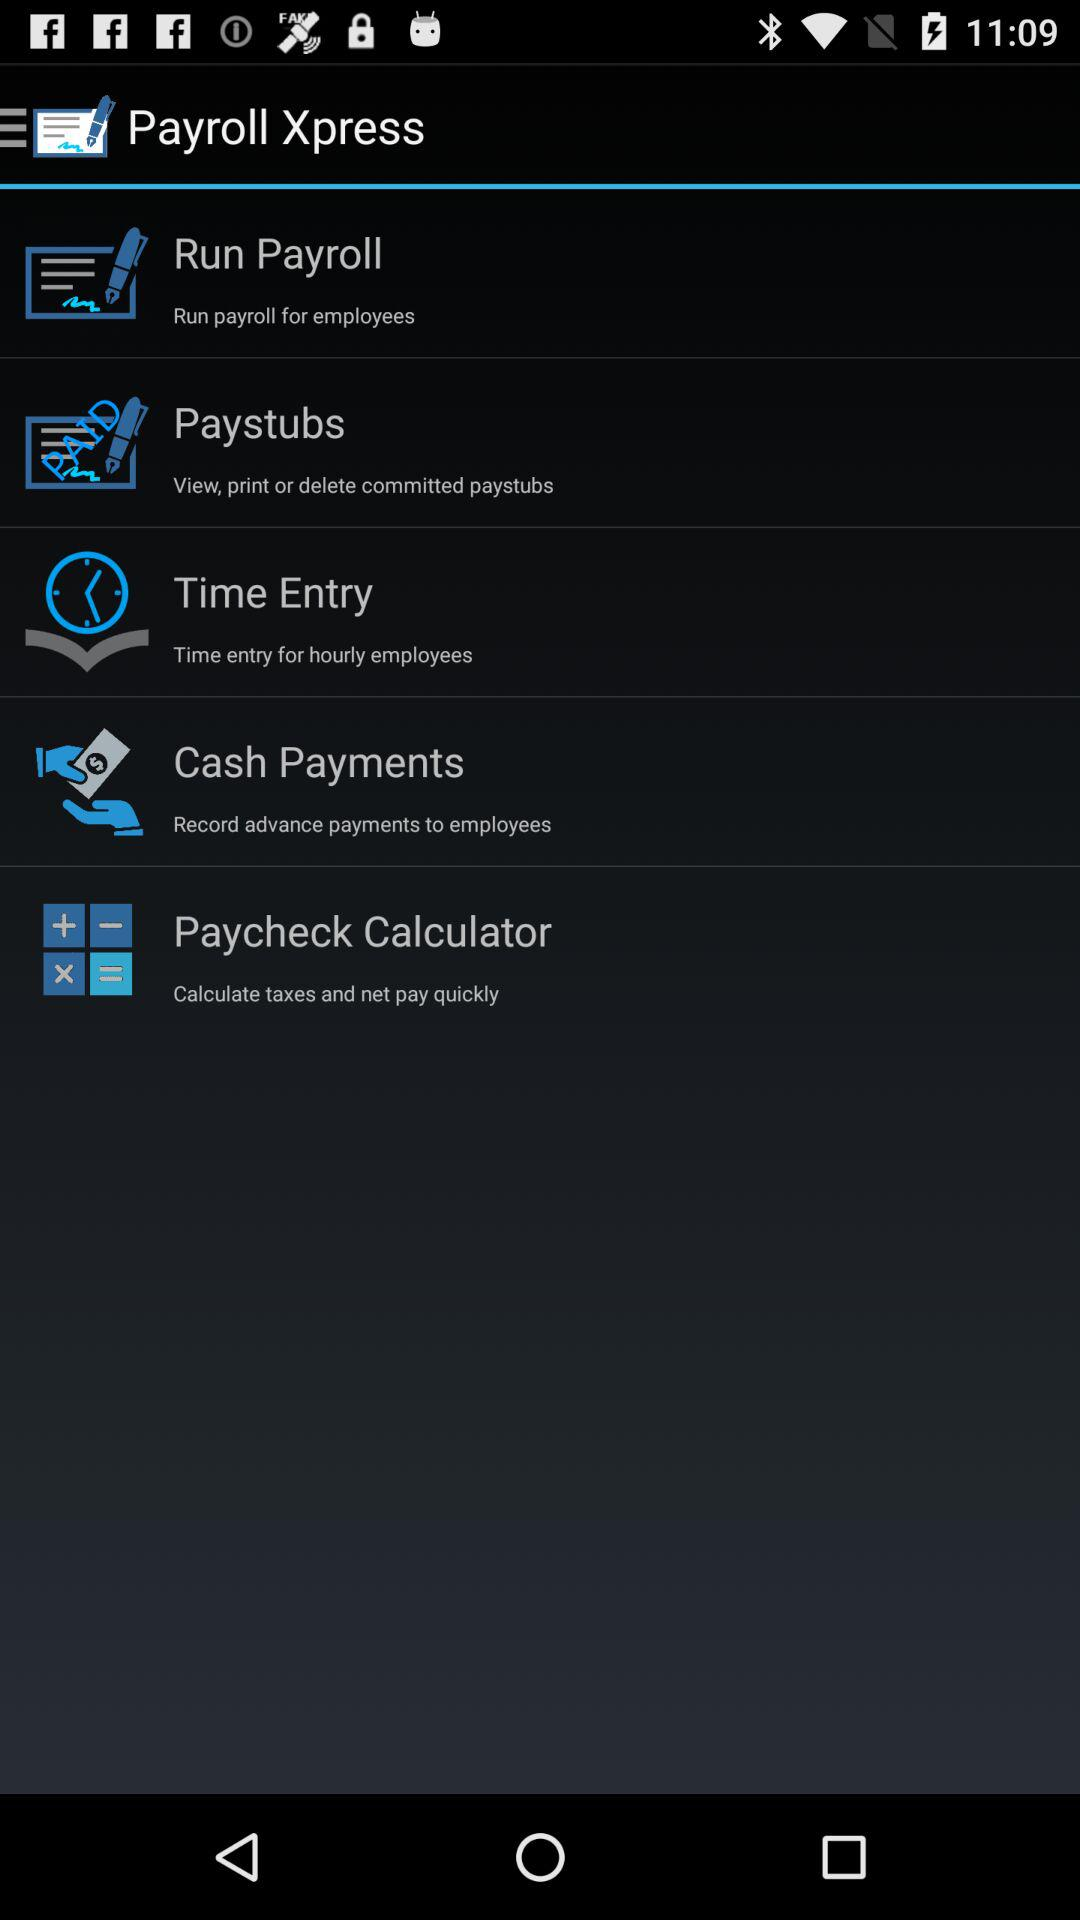What is the application name? The application name is "Payroll Xpress". 